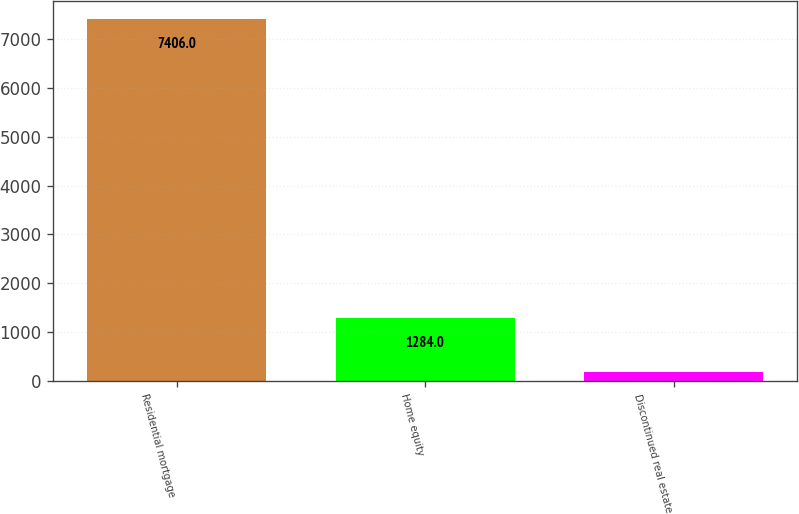<chart> <loc_0><loc_0><loc_500><loc_500><bar_chart><fcel>Residential mortgage<fcel>Home equity<fcel>Discontinued real estate<nl><fcel>7406<fcel>1284<fcel>177<nl></chart> 